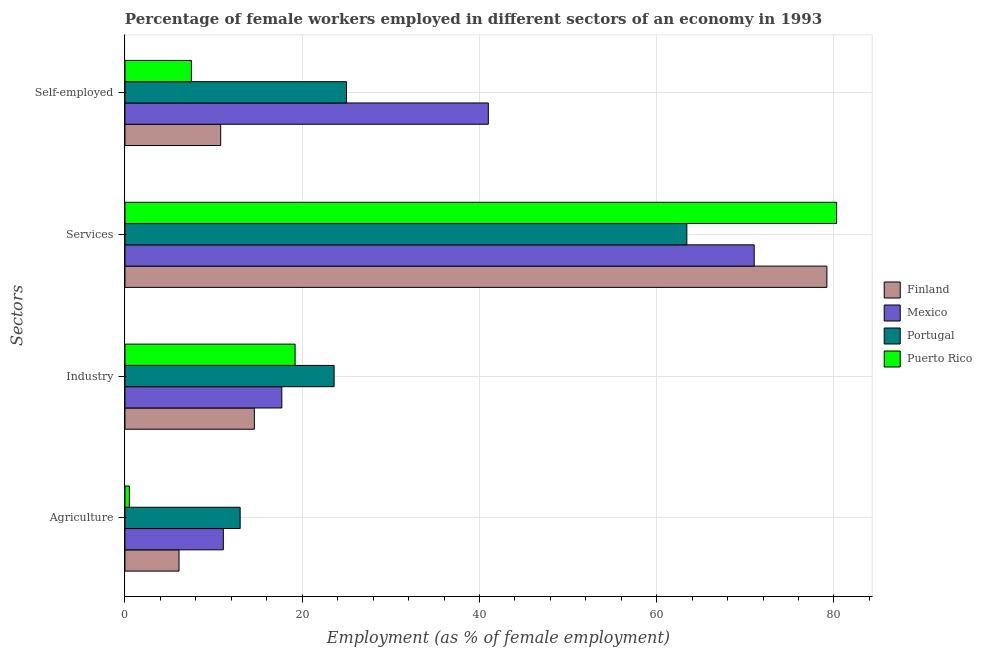How many different coloured bars are there?
Ensure brevity in your answer.  4. How many groups of bars are there?
Give a very brief answer. 4. Are the number of bars per tick equal to the number of legend labels?
Offer a terse response. Yes. How many bars are there on the 1st tick from the bottom?
Your answer should be compact. 4. What is the label of the 3rd group of bars from the top?
Your answer should be compact. Industry. What is the percentage of self employed female workers in Mexico?
Ensure brevity in your answer.  41. Across all countries, what is the maximum percentage of self employed female workers?
Your answer should be compact. 41. Across all countries, what is the minimum percentage of female workers in industry?
Offer a very short reply. 14.6. In which country was the percentage of female workers in services maximum?
Provide a short and direct response. Puerto Rico. What is the total percentage of female workers in industry in the graph?
Make the answer very short. 75.1. What is the difference between the percentage of self employed female workers in Mexico and that in Finland?
Your response must be concise. 30.2. What is the difference between the percentage of female workers in services in Finland and the percentage of female workers in industry in Puerto Rico?
Provide a short and direct response. 60. What is the average percentage of female workers in agriculture per country?
Your answer should be very brief. 7.68. What is the difference between the percentage of female workers in industry and percentage of female workers in agriculture in Portugal?
Ensure brevity in your answer.  10.6. What is the ratio of the percentage of female workers in industry in Finland to that in Puerto Rico?
Your answer should be very brief. 0.76. What is the difference between the highest and the second highest percentage of female workers in agriculture?
Offer a very short reply. 1.9. What is the difference between the highest and the lowest percentage of female workers in industry?
Keep it short and to the point. 9. In how many countries, is the percentage of female workers in industry greater than the average percentage of female workers in industry taken over all countries?
Give a very brief answer. 2. Is the sum of the percentage of self employed female workers in Mexico and Finland greater than the maximum percentage of female workers in services across all countries?
Provide a succinct answer. No. Is it the case that in every country, the sum of the percentage of female workers in industry and percentage of female workers in agriculture is greater than the sum of percentage of female workers in services and percentage of self employed female workers?
Offer a terse response. No. What does the 1st bar from the top in Self-employed represents?
Make the answer very short. Puerto Rico. Is it the case that in every country, the sum of the percentage of female workers in agriculture and percentage of female workers in industry is greater than the percentage of female workers in services?
Your answer should be very brief. No. Are all the bars in the graph horizontal?
Give a very brief answer. Yes. Does the graph contain any zero values?
Your answer should be compact. No. How many legend labels are there?
Offer a very short reply. 4. How are the legend labels stacked?
Provide a succinct answer. Vertical. What is the title of the graph?
Your answer should be very brief. Percentage of female workers employed in different sectors of an economy in 1993. Does "Caribbean small states" appear as one of the legend labels in the graph?
Provide a succinct answer. No. What is the label or title of the X-axis?
Offer a terse response. Employment (as % of female employment). What is the label or title of the Y-axis?
Give a very brief answer. Sectors. What is the Employment (as % of female employment) in Finland in Agriculture?
Provide a short and direct response. 6.1. What is the Employment (as % of female employment) in Mexico in Agriculture?
Your answer should be compact. 11.1. What is the Employment (as % of female employment) of Portugal in Agriculture?
Provide a short and direct response. 13. What is the Employment (as % of female employment) of Finland in Industry?
Keep it short and to the point. 14.6. What is the Employment (as % of female employment) in Mexico in Industry?
Offer a terse response. 17.7. What is the Employment (as % of female employment) in Portugal in Industry?
Make the answer very short. 23.6. What is the Employment (as % of female employment) of Puerto Rico in Industry?
Make the answer very short. 19.2. What is the Employment (as % of female employment) in Finland in Services?
Your answer should be compact. 79.2. What is the Employment (as % of female employment) in Mexico in Services?
Offer a very short reply. 71. What is the Employment (as % of female employment) of Portugal in Services?
Ensure brevity in your answer.  63.4. What is the Employment (as % of female employment) in Puerto Rico in Services?
Ensure brevity in your answer.  80.3. What is the Employment (as % of female employment) in Finland in Self-employed?
Offer a terse response. 10.8. What is the Employment (as % of female employment) in Mexico in Self-employed?
Your response must be concise. 41. What is the Employment (as % of female employment) of Portugal in Self-employed?
Your answer should be very brief. 25. Across all Sectors, what is the maximum Employment (as % of female employment) in Finland?
Offer a very short reply. 79.2. Across all Sectors, what is the maximum Employment (as % of female employment) of Mexico?
Offer a very short reply. 71. Across all Sectors, what is the maximum Employment (as % of female employment) in Portugal?
Give a very brief answer. 63.4. Across all Sectors, what is the maximum Employment (as % of female employment) of Puerto Rico?
Offer a very short reply. 80.3. Across all Sectors, what is the minimum Employment (as % of female employment) of Finland?
Keep it short and to the point. 6.1. Across all Sectors, what is the minimum Employment (as % of female employment) of Mexico?
Your response must be concise. 11.1. Across all Sectors, what is the minimum Employment (as % of female employment) of Portugal?
Keep it short and to the point. 13. Across all Sectors, what is the minimum Employment (as % of female employment) in Puerto Rico?
Offer a terse response. 0.5. What is the total Employment (as % of female employment) in Finland in the graph?
Provide a short and direct response. 110.7. What is the total Employment (as % of female employment) of Mexico in the graph?
Your answer should be very brief. 140.8. What is the total Employment (as % of female employment) in Portugal in the graph?
Provide a succinct answer. 125. What is the total Employment (as % of female employment) of Puerto Rico in the graph?
Make the answer very short. 107.5. What is the difference between the Employment (as % of female employment) in Portugal in Agriculture and that in Industry?
Give a very brief answer. -10.6. What is the difference between the Employment (as % of female employment) in Puerto Rico in Agriculture and that in Industry?
Keep it short and to the point. -18.7. What is the difference between the Employment (as % of female employment) in Finland in Agriculture and that in Services?
Offer a very short reply. -73.1. What is the difference between the Employment (as % of female employment) of Mexico in Agriculture and that in Services?
Keep it short and to the point. -59.9. What is the difference between the Employment (as % of female employment) in Portugal in Agriculture and that in Services?
Make the answer very short. -50.4. What is the difference between the Employment (as % of female employment) in Puerto Rico in Agriculture and that in Services?
Your response must be concise. -79.8. What is the difference between the Employment (as % of female employment) in Finland in Agriculture and that in Self-employed?
Offer a terse response. -4.7. What is the difference between the Employment (as % of female employment) of Mexico in Agriculture and that in Self-employed?
Your answer should be very brief. -29.9. What is the difference between the Employment (as % of female employment) of Finland in Industry and that in Services?
Provide a short and direct response. -64.6. What is the difference between the Employment (as % of female employment) of Mexico in Industry and that in Services?
Keep it short and to the point. -53.3. What is the difference between the Employment (as % of female employment) of Portugal in Industry and that in Services?
Make the answer very short. -39.8. What is the difference between the Employment (as % of female employment) of Puerto Rico in Industry and that in Services?
Your answer should be very brief. -61.1. What is the difference between the Employment (as % of female employment) in Finland in Industry and that in Self-employed?
Provide a short and direct response. 3.8. What is the difference between the Employment (as % of female employment) of Mexico in Industry and that in Self-employed?
Offer a terse response. -23.3. What is the difference between the Employment (as % of female employment) of Portugal in Industry and that in Self-employed?
Make the answer very short. -1.4. What is the difference between the Employment (as % of female employment) of Puerto Rico in Industry and that in Self-employed?
Make the answer very short. 11.7. What is the difference between the Employment (as % of female employment) in Finland in Services and that in Self-employed?
Provide a succinct answer. 68.4. What is the difference between the Employment (as % of female employment) in Portugal in Services and that in Self-employed?
Your answer should be very brief. 38.4. What is the difference between the Employment (as % of female employment) of Puerto Rico in Services and that in Self-employed?
Your answer should be compact. 72.8. What is the difference between the Employment (as % of female employment) in Finland in Agriculture and the Employment (as % of female employment) in Portugal in Industry?
Make the answer very short. -17.5. What is the difference between the Employment (as % of female employment) of Mexico in Agriculture and the Employment (as % of female employment) of Portugal in Industry?
Offer a very short reply. -12.5. What is the difference between the Employment (as % of female employment) of Finland in Agriculture and the Employment (as % of female employment) of Mexico in Services?
Make the answer very short. -64.9. What is the difference between the Employment (as % of female employment) of Finland in Agriculture and the Employment (as % of female employment) of Portugal in Services?
Offer a terse response. -57.3. What is the difference between the Employment (as % of female employment) in Finland in Agriculture and the Employment (as % of female employment) in Puerto Rico in Services?
Your answer should be very brief. -74.2. What is the difference between the Employment (as % of female employment) in Mexico in Agriculture and the Employment (as % of female employment) in Portugal in Services?
Offer a very short reply. -52.3. What is the difference between the Employment (as % of female employment) of Mexico in Agriculture and the Employment (as % of female employment) of Puerto Rico in Services?
Your answer should be very brief. -69.2. What is the difference between the Employment (as % of female employment) of Portugal in Agriculture and the Employment (as % of female employment) of Puerto Rico in Services?
Provide a succinct answer. -67.3. What is the difference between the Employment (as % of female employment) of Finland in Agriculture and the Employment (as % of female employment) of Mexico in Self-employed?
Provide a succinct answer. -34.9. What is the difference between the Employment (as % of female employment) in Finland in Agriculture and the Employment (as % of female employment) in Portugal in Self-employed?
Your answer should be very brief. -18.9. What is the difference between the Employment (as % of female employment) in Mexico in Agriculture and the Employment (as % of female employment) in Puerto Rico in Self-employed?
Keep it short and to the point. 3.6. What is the difference between the Employment (as % of female employment) in Portugal in Agriculture and the Employment (as % of female employment) in Puerto Rico in Self-employed?
Your response must be concise. 5.5. What is the difference between the Employment (as % of female employment) in Finland in Industry and the Employment (as % of female employment) in Mexico in Services?
Your answer should be very brief. -56.4. What is the difference between the Employment (as % of female employment) of Finland in Industry and the Employment (as % of female employment) of Portugal in Services?
Your response must be concise. -48.8. What is the difference between the Employment (as % of female employment) in Finland in Industry and the Employment (as % of female employment) in Puerto Rico in Services?
Provide a short and direct response. -65.7. What is the difference between the Employment (as % of female employment) in Mexico in Industry and the Employment (as % of female employment) in Portugal in Services?
Your response must be concise. -45.7. What is the difference between the Employment (as % of female employment) in Mexico in Industry and the Employment (as % of female employment) in Puerto Rico in Services?
Make the answer very short. -62.6. What is the difference between the Employment (as % of female employment) in Portugal in Industry and the Employment (as % of female employment) in Puerto Rico in Services?
Your response must be concise. -56.7. What is the difference between the Employment (as % of female employment) in Finland in Industry and the Employment (as % of female employment) in Mexico in Self-employed?
Your answer should be compact. -26.4. What is the difference between the Employment (as % of female employment) in Finland in Industry and the Employment (as % of female employment) in Portugal in Self-employed?
Provide a succinct answer. -10.4. What is the difference between the Employment (as % of female employment) of Finland in Industry and the Employment (as % of female employment) of Puerto Rico in Self-employed?
Provide a short and direct response. 7.1. What is the difference between the Employment (as % of female employment) in Portugal in Industry and the Employment (as % of female employment) in Puerto Rico in Self-employed?
Ensure brevity in your answer.  16.1. What is the difference between the Employment (as % of female employment) in Finland in Services and the Employment (as % of female employment) in Mexico in Self-employed?
Your answer should be compact. 38.2. What is the difference between the Employment (as % of female employment) of Finland in Services and the Employment (as % of female employment) of Portugal in Self-employed?
Provide a succinct answer. 54.2. What is the difference between the Employment (as % of female employment) of Finland in Services and the Employment (as % of female employment) of Puerto Rico in Self-employed?
Provide a short and direct response. 71.7. What is the difference between the Employment (as % of female employment) of Mexico in Services and the Employment (as % of female employment) of Puerto Rico in Self-employed?
Keep it short and to the point. 63.5. What is the difference between the Employment (as % of female employment) in Portugal in Services and the Employment (as % of female employment) in Puerto Rico in Self-employed?
Make the answer very short. 55.9. What is the average Employment (as % of female employment) in Finland per Sectors?
Your response must be concise. 27.68. What is the average Employment (as % of female employment) in Mexico per Sectors?
Offer a very short reply. 35.2. What is the average Employment (as % of female employment) in Portugal per Sectors?
Give a very brief answer. 31.25. What is the average Employment (as % of female employment) of Puerto Rico per Sectors?
Offer a terse response. 26.88. What is the difference between the Employment (as % of female employment) of Finland and Employment (as % of female employment) of Portugal in Agriculture?
Your answer should be very brief. -6.9. What is the difference between the Employment (as % of female employment) in Finland and Employment (as % of female employment) in Puerto Rico in Agriculture?
Your answer should be compact. 5.6. What is the difference between the Employment (as % of female employment) in Mexico and Employment (as % of female employment) in Puerto Rico in Agriculture?
Provide a short and direct response. 10.6. What is the difference between the Employment (as % of female employment) in Portugal and Employment (as % of female employment) in Puerto Rico in Agriculture?
Provide a short and direct response. 12.5. What is the difference between the Employment (as % of female employment) in Finland and Employment (as % of female employment) in Mexico in Industry?
Give a very brief answer. -3.1. What is the difference between the Employment (as % of female employment) in Finland and Employment (as % of female employment) in Portugal in Industry?
Your answer should be compact. -9. What is the difference between the Employment (as % of female employment) of Mexico and Employment (as % of female employment) of Portugal in Industry?
Ensure brevity in your answer.  -5.9. What is the difference between the Employment (as % of female employment) in Finland and Employment (as % of female employment) in Puerto Rico in Services?
Offer a terse response. -1.1. What is the difference between the Employment (as % of female employment) in Mexico and Employment (as % of female employment) in Portugal in Services?
Your answer should be compact. 7.6. What is the difference between the Employment (as % of female employment) of Portugal and Employment (as % of female employment) of Puerto Rico in Services?
Your response must be concise. -16.9. What is the difference between the Employment (as % of female employment) in Finland and Employment (as % of female employment) in Mexico in Self-employed?
Offer a terse response. -30.2. What is the difference between the Employment (as % of female employment) in Mexico and Employment (as % of female employment) in Puerto Rico in Self-employed?
Your response must be concise. 33.5. What is the difference between the Employment (as % of female employment) in Portugal and Employment (as % of female employment) in Puerto Rico in Self-employed?
Keep it short and to the point. 17.5. What is the ratio of the Employment (as % of female employment) of Finland in Agriculture to that in Industry?
Give a very brief answer. 0.42. What is the ratio of the Employment (as % of female employment) in Mexico in Agriculture to that in Industry?
Your answer should be compact. 0.63. What is the ratio of the Employment (as % of female employment) in Portugal in Agriculture to that in Industry?
Keep it short and to the point. 0.55. What is the ratio of the Employment (as % of female employment) of Puerto Rico in Agriculture to that in Industry?
Your response must be concise. 0.03. What is the ratio of the Employment (as % of female employment) of Finland in Agriculture to that in Services?
Provide a short and direct response. 0.08. What is the ratio of the Employment (as % of female employment) of Mexico in Agriculture to that in Services?
Your answer should be very brief. 0.16. What is the ratio of the Employment (as % of female employment) in Portugal in Agriculture to that in Services?
Your answer should be compact. 0.2. What is the ratio of the Employment (as % of female employment) in Puerto Rico in Agriculture to that in Services?
Keep it short and to the point. 0.01. What is the ratio of the Employment (as % of female employment) in Finland in Agriculture to that in Self-employed?
Give a very brief answer. 0.56. What is the ratio of the Employment (as % of female employment) of Mexico in Agriculture to that in Self-employed?
Your answer should be compact. 0.27. What is the ratio of the Employment (as % of female employment) of Portugal in Agriculture to that in Self-employed?
Give a very brief answer. 0.52. What is the ratio of the Employment (as % of female employment) in Puerto Rico in Agriculture to that in Self-employed?
Your answer should be very brief. 0.07. What is the ratio of the Employment (as % of female employment) of Finland in Industry to that in Services?
Keep it short and to the point. 0.18. What is the ratio of the Employment (as % of female employment) of Mexico in Industry to that in Services?
Offer a terse response. 0.25. What is the ratio of the Employment (as % of female employment) in Portugal in Industry to that in Services?
Give a very brief answer. 0.37. What is the ratio of the Employment (as % of female employment) of Puerto Rico in Industry to that in Services?
Your answer should be compact. 0.24. What is the ratio of the Employment (as % of female employment) of Finland in Industry to that in Self-employed?
Give a very brief answer. 1.35. What is the ratio of the Employment (as % of female employment) in Mexico in Industry to that in Self-employed?
Provide a succinct answer. 0.43. What is the ratio of the Employment (as % of female employment) in Portugal in Industry to that in Self-employed?
Keep it short and to the point. 0.94. What is the ratio of the Employment (as % of female employment) of Puerto Rico in Industry to that in Self-employed?
Make the answer very short. 2.56. What is the ratio of the Employment (as % of female employment) in Finland in Services to that in Self-employed?
Keep it short and to the point. 7.33. What is the ratio of the Employment (as % of female employment) of Mexico in Services to that in Self-employed?
Your answer should be very brief. 1.73. What is the ratio of the Employment (as % of female employment) in Portugal in Services to that in Self-employed?
Offer a very short reply. 2.54. What is the ratio of the Employment (as % of female employment) of Puerto Rico in Services to that in Self-employed?
Provide a succinct answer. 10.71. What is the difference between the highest and the second highest Employment (as % of female employment) of Finland?
Your answer should be compact. 64.6. What is the difference between the highest and the second highest Employment (as % of female employment) of Portugal?
Your response must be concise. 38.4. What is the difference between the highest and the second highest Employment (as % of female employment) of Puerto Rico?
Give a very brief answer. 61.1. What is the difference between the highest and the lowest Employment (as % of female employment) in Finland?
Provide a succinct answer. 73.1. What is the difference between the highest and the lowest Employment (as % of female employment) of Mexico?
Ensure brevity in your answer.  59.9. What is the difference between the highest and the lowest Employment (as % of female employment) in Portugal?
Your answer should be very brief. 50.4. What is the difference between the highest and the lowest Employment (as % of female employment) of Puerto Rico?
Ensure brevity in your answer.  79.8. 